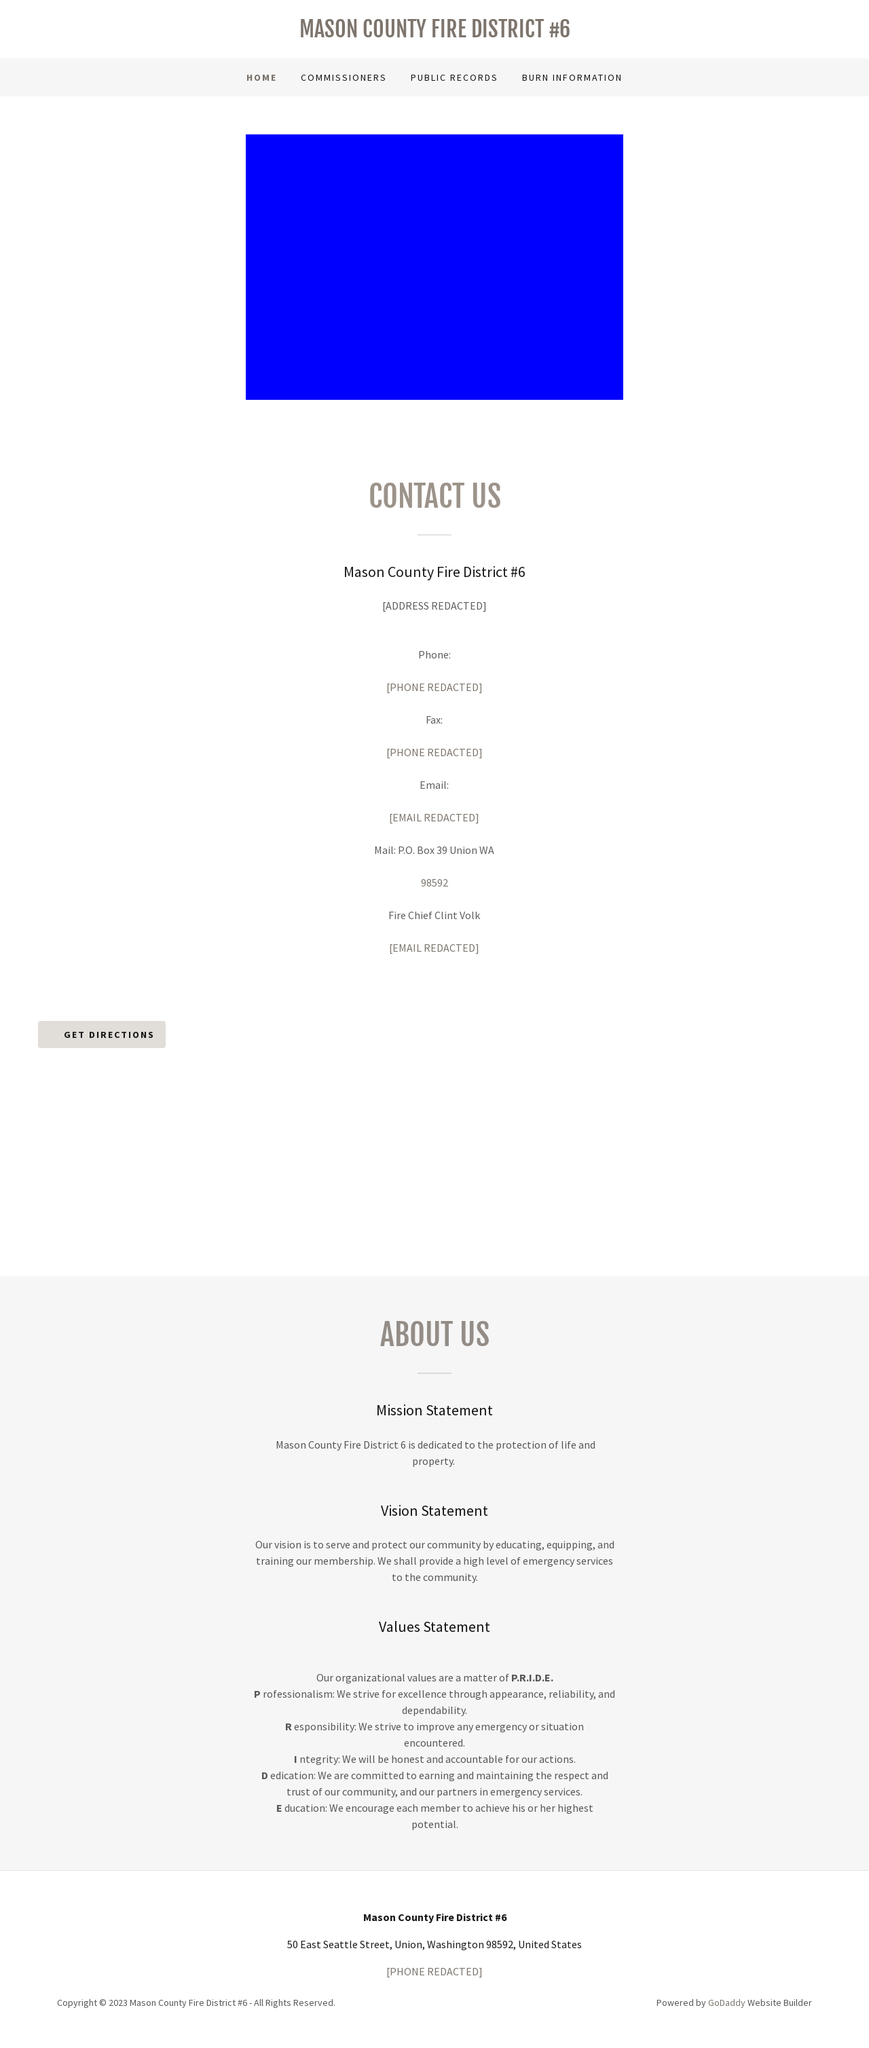Could you guide me through the process of developing this website with HTML? Certainly! When developing a website similar to the Mason County Fire District #6 website, you'll start by defining the HTML structure. Begin with basic tags like <!DOCTYPE html>, <html>, <head>, and <body>. Inside the <head>, include meta tags for charset, viewport, and SEO-related tags like title and description. Usage of <header>, <nav>, and <footer> structures will semantically divide the content. Styling is managed through linked CSS files or inline styles within <style> tags. The body of your HTML will contain sections like 'Contact Us' and 'About Us', each typically wrapped in <div> or <section> tags, with <h1> to <h6> tags for headings and <p> tags for paragraphs. Integrating interactive elements like the 'Get Directions' button might involve some JavaScript. Always ensure to make your website responsive by using media queries and flexible grid layouts. 